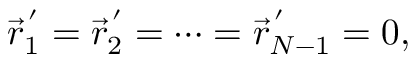<formula> <loc_0><loc_0><loc_500><loc_500>\vec { r } _ { 1 } ^ { \, ^ { \prime } } = \vec { r } _ { 2 } ^ { \, ^ { \prime } } = \cdots = \vec { r } _ { N - 1 } ^ { \, ^ { \prime } } = 0 ,</formula> 